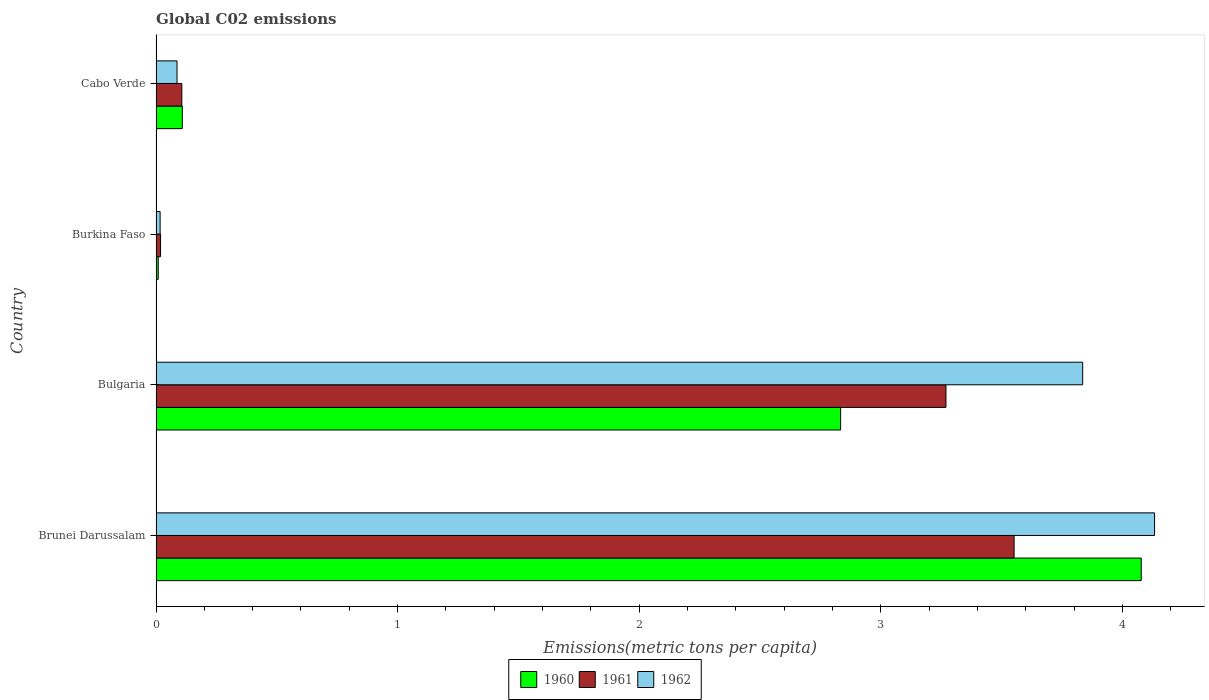How many different coloured bars are there?
Keep it short and to the point. 3. What is the amount of CO2 emitted in in 1961 in Burkina Faso?
Ensure brevity in your answer.  0.02. Across all countries, what is the maximum amount of CO2 emitted in in 1961?
Your response must be concise. 3.55. Across all countries, what is the minimum amount of CO2 emitted in in 1961?
Provide a succinct answer. 0.02. In which country was the amount of CO2 emitted in in 1962 maximum?
Your response must be concise. Brunei Darussalam. In which country was the amount of CO2 emitted in in 1961 minimum?
Provide a succinct answer. Burkina Faso. What is the total amount of CO2 emitted in in 1960 in the graph?
Provide a short and direct response. 7.03. What is the difference between the amount of CO2 emitted in in 1961 in Brunei Darussalam and that in Cabo Verde?
Give a very brief answer. 3.45. What is the difference between the amount of CO2 emitted in in 1961 in Brunei Darussalam and the amount of CO2 emitted in in 1962 in Bulgaria?
Ensure brevity in your answer.  -0.28. What is the average amount of CO2 emitted in in 1960 per country?
Make the answer very short. 1.76. What is the difference between the amount of CO2 emitted in in 1962 and amount of CO2 emitted in in 1960 in Burkina Faso?
Offer a terse response. 0.01. In how many countries, is the amount of CO2 emitted in in 1960 greater than 2.6 metric tons per capita?
Give a very brief answer. 2. What is the ratio of the amount of CO2 emitted in in 1962 in Bulgaria to that in Burkina Faso?
Offer a very short reply. 225.6. Is the difference between the amount of CO2 emitted in in 1962 in Brunei Darussalam and Burkina Faso greater than the difference between the amount of CO2 emitted in in 1960 in Brunei Darussalam and Burkina Faso?
Your answer should be compact. Yes. What is the difference between the highest and the second highest amount of CO2 emitted in in 1961?
Your response must be concise. 0.28. What is the difference between the highest and the lowest amount of CO2 emitted in in 1960?
Your response must be concise. 4.07. Is the sum of the amount of CO2 emitted in in 1961 in Brunei Darussalam and Bulgaria greater than the maximum amount of CO2 emitted in in 1960 across all countries?
Offer a terse response. Yes. How many bars are there?
Provide a succinct answer. 12. How many countries are there in the graph?
Offer a very short reply. 4. What is the difference between two consecutive major ticks on the X-axis?
Give a very brief answer. 1. Are the values on the major ticks of X-axis written in scientific E-notation?
Your answer should be very brief. No. Does the graph contain any zero values?
Ensure brevity in your answer.  No. Where does the legend appear in the graph?
Your response must be concise. Bottom center. What is the title of the graph?
Provide a short and direct response. Global C02 emissions. What is the label or title of the X-axis?
Offer a terse response. Emissions(metric tons per capita). What is the Emissions(metric tons per capita) in 1960 in Brunei Darussalam?
Your answer should be very brief. 4.08. What is the Emissions(metric tons per capita) in 1961 in Brunei Darussalam?
Provide a succinct answer. 3.55. What is the Emissions(metric tons per capita) in 1962 in Brunei Darussalam?
Provide a short and direct response. 4.13. What is the Emissions(metric tons per capita) in 1960 in Bulgaria?
Provide a short and direct response. 2.83. What is the Emissions(metric tons per capita) in 1961 in Bulgaria?
Offer a very short reply. 3.27. What is the Emissions(metric tons per capita) of 1962 in Bulgaria?
Your response must be concise. 3.84. What is the Emissions(metric tons per capita) in 1960 in Burkina Faso?
Offer a terse response. 0.01. What is the Emissions(metric tons per capita) in 1961 in Burkina Faso?
Your answer should be very brief. 0.02. What is the Emissions(metric tons per capita) of 1962 in Burkina Faso?
Provide a succinct answer. 0.02. What is the Emissions(metric tons per capita) in 1960 in Cabo Verde?
Make the answer very short. 0.11. What is the Emissions(metric tons per capita) of 1961 in Cabo Verde?
Give a very brief answer. 0.11. What is the Emissions(metric tons per capita) of 1962 in Cabo Verde?
Give a very brief answer. 0.09. Across all countries, what is the maximum Emissions(metric tons per capita) of 1960?
Offer a terse response. 4.08. Across all countries, what is the maximum Emissions(metric tons per capita) of 1961?
Ensure brevity in your answer.  3.55. Across all countries, what is the maximum Emissions(metric tons per capita) of 1962?
Your response must be concise. 4.13. Across all countries, what is the minimum Emissions(metric tons per capita) in 1960?
Provide a succinct answer. 0.01. Across all countries, what is the minimum Emissions(metric tons per capita) of 1961?
Your response must be concise. 0.02. Across all countries, what is the minimum Emissions(metric tons per capita) of 1962?
Your answer should be very brief. 0.02. What is the total Emissions(metric tons per capita) of 1960 in the graph?
Your response must be concise. 7.03. What is the total Emissions(metric tons per capita) in 1961 in the graph?
Your response must be concise. 6.95. What is the total Emissions(metric tons per capita) in 1962 in the graph?
Provide a short and direct response. 8.07. What is the difference between the Emissions(metric tons per capita) of 1960 in Brunei Darussalam and that in Bulgaria?
Make the answer very short. 1.24. What is the difference between the Emissions(metric tons per capita) in 1961 in Brunei Darussalam and that in Bulgaria?
Keep it short and to the point. 0.28. What is the difference between the Emissions(metric tons per capita) in 1962 in Brunei Darussalam and that in Bulgaria?
Ensure brevity in your answer.  0.3. What is the difference between the Emissions(metric tons per capita) in 1960 in Brunei Darussalam and that in Burkina Faso?
Keep it short and to the point. 4.07. What is the difference between the Emissions(metric tons per capita) of 1961 in Brunei Darussalam and that in Burkina Faso?
Keep it short and to the point. 3.53. What is the difference between the Emissions(metric tons per capita) in 1962 in Brunei Darussalam and that in Burkina Faso?
Your answer should be compact. 4.12. What is the difference between the Emissions(metric tons per capita) of 1960 in Brunei Darussalam and that in Cabo Verde?
Offer a terse response. 3.97. What is the difference between the Emissions(metric tons per capita) in 1961 in Brunei Darussalam and that in Cabo Verde?
Your answer should be compact. 3.45. What is the difference between the Emissions(metric tons per capita) in 1962 in Brunei Darussalam and that in Cabo Verde?
Your answer should be very brief. 4.05. What is the difference between the Emissions(metric tons per capita) in 1960 in Bulgaria and that in Burkina Faso?
Make the answer very short. 2.82. What is the difference between the Emissions(metric tons per capita) in 1961 in Bulgaria and that in Burkina Faso?
Give a very brief answer. 3.25. What is the difference between the Emissions(metric tons per capita) of 1962 in Bulgaria and that in Burkina Faso?
Ensure brevity in your answer.  3.82. What is the difference between the Emissions(metric tons per capita) in 1960 in Bulgaria and that in Cabo Verde?
Your answer should be very brief. 2.73. What is the difference between the Emissions(metric tons per capita) in 1961 in Bulgaria and that in Cabo Verde?
Make the answer very short. 3.16. What is the difference between the Emissions(metric tons per capita) of 1962 in Bulgaria and that in Cabo Verde?
Your answer should be compact. 3.75. What is the difference between the Emissions(metric tons per capita) of 1960 in Burkina Faso and that in Cabo Verde?
Offer a very short reply. -0.1. What is the difference between the Emissions(metric tons per capita) in 1961 in Burkina Faso and that in Cabo Verde?
Offer a terse response. -0.09. What is the difference between the Emissions(metric tons per capita) in 1962 in Burkina Faso and that in Cabo Verde?
Ensure brevity in your answer.  -0.07. What is the difference between the Emissions(metric tons per capita) in 1960 in Brunei Darussalam and the Emissions(metric tons per capita) in 1961 in Bulgaria?
Keep it short and to the point. 0.81. What is the difference between the Emissions(metric tons per capita) in 1960 in Brunei Darussalam and the Emissions(metric tons per capita) in 1962 in Bulgaria?
Ensure brevity in your answer.  0.24. What is the difference between the Emissions(metric tons per capita) of 1961 in Brunei Darussalam and the Emissions(metric tons per capita) of 1962 in Bulgaria?
Your response must be concise. -0.28. What is the difference between the Emissions(metric tons per capita) in 1960 in Brunei Darussalam and the Emissions(metric tons per capita) in 1961 in Burkina Faso?
Offer a very short reply. 4.06. What is the difference between the Emissions(metric tons per capita) of 1960 in Brunei Darussalam and the Emissions(metric tons per capita) of 1962 in Burkina Faso?
Provide a short and direct response. 4.06. What is the difference between the Emissions(metric tons per capita) of 1961 in Brunei Darussalam and the Emissions(metric tons per capita) of 1962 in Burkina Faso?
Ensure brevity in your answer.  3.54. What is the difference between the Emissions(metric tons per capita) of 1960 in Brunei Darussalam and the Emissions(metric tons per capita) of 1961 in Cabo Verde?
Offer a terse response. 3.97. What is the difference between the Emissions(metric tons per capita) of 1960 in Brunei Darussalam and the Emissions(metric tons per capita) of 1962 in Cabo Verde?
Provide a short and direct response. 3.99. What is the difference between the Emissions(metric tons per capita) of 1961 in Brunei Darussalam and the Emissions(metric tons per capita) of 1962 in Cabo Verde?
Your answer should be compact. 3.47. What is the difference between the Emissions(metric tons per capita) in 1960 in Bulgaria and the Emissions(metric tons per capita) in 1961 in Burkina Faso?
Your answer should be very brief. 2.82. What is the difference between the Emissions(metric tons per capita) in 1960 in Bulgaria and the Emissions(metric tons per capita) in 1962 in Burkina Faso?
Keep it short and to the point. 2.82. What is the difference between the Emissions(metric tons per capita) in 1961 in Bulgaria and the Emissions(metric tons per capita) in 1962 in Burkina Faso?
Your answer should be very brief. 3.25. What is the difference between the Emissions(metric tons per capita) of 1960 in Bulgaria and the Emissions(metric tons per capita) of 1961 in Cabo Verde?
Your answer should be very brief. 2.73. What is the difference between the Emissions(metric tons per capita) of 1960 in Bulgaria and the Emissions(metric tons per capita) of 1962 in Cabo Verde?
Your response must be concise. 2.75. What is the difference between the Emissions(metric tons per capita) in 1961 in Bulgaria and the Emissions(metric tons per capita) in 1962 in Cabo Verde?
Provide a short and direct response. 3.18. What is the difference between the Emissions(metric tons per capita) in 1960 in Burkina Faso and the Emissions(metric tons per capita) in 1961 in Cabo Verde?
Provide a short and direct response. -0.1. What is the difference between the Emissions(metric tons per capita) of 1960 in Burkina Faso and the Emissions(metric tons per capita) of 1962 in Cabo Verde?
Provide a succinct answer. -0.08. What is the difference between the Emissions(metric tons per capita) of 1961 in Burkina Faso and the Emissions(metric tons per capita) of 1962 in Cabo Verde?
Offer a very short reply. -0.07. What is the average Emissions(metric tons per capita) of 1960 per country?
Ensure brevity in your answer.  1.76. What is the average Emissions(metric tons per capita) in 1961 per country?
Offer a terse response. 1.74. What is the average Emissions(metric tons per capita) in 1962 per country?
Offer a terse response. 2.02. What is the difference between the Emissions(metric tons per capita) of 1960 and Emissions(metric tons per capita) of 1961 in Brunei Darussalam?
Provide a short and direct response. 0.53. What is the difference between the Emissions(metric tons per capita) in 1960 and Emissions(metric tons per capita) in 1962 in Brunei Darussalam?
Your answer should be compact. -0.06. What is the difference between the Emissions(metric tons per capita) in 1961 and Emissions(metric tons per capita) in 1962 in Brunei Darussalam?
Keep it short and to the point. -0.58. What is the difference between the Emissions(metric tons per capita) of 1960 and Emissions(metric tons per capita) of 1961 in Bulgaria?
Ensure brevity in your answer.  -0.44. What is the difference between the Emissions(metric tons per capita) in 1960 and Emissions(metric tons per capita) in 1962 in Bulgaria?
Offer a very short reply. -1. What is the difference between the Emissions(metric tons per capita) in 1961 and Emissions(metric tons per capita) in 1962 in Bulgaria?
Offer a terse response. -0.57. What is the difference between the Emissions(metric tons per capita) of 1960 and Emissions(metric tons per capita) of 1961 in Burkina Faso?
Provide a short and direct response. -0.01. What is the difference between the Emissions(metric tons per capita) of 1960 and Emissions(metric tons per capita) of 1962 in Burkina Faso?
Your answer should be compact. -0.01. What is the difference between the Emissions(metric tons per capita) of 1961 and Emissions(metric tons per capita) of 1962 in Burkina Faso?
Ensure brevity in your answer.  0. What is the difference between the Emissions(metric tons per capita) in 1960 and Emissions(metric tons per capita) in 1961 in Cabo Verde?
Offer a very short reply. 0. What is the difference between the Emissions(metric tons per capita) of 1960 and Emissions(metric tons per capita) of 1962 in Cabo Verde?
Offer a very short reply. 0.02. What is the difference between the Emissions(metric tons per capita) in 1961 and Emissions(metric tons per capita) in 1962 in Cabo Verde?
Give a very brief answer. 0.02. What is the ratio of the Emissions(metric tons per capita) in 1960 in Brunei Darussalam to that in Bulgaria?
Give a very brief answer. 1.44. What is the ratio of the Emissions(metric tons per capita) in 1961 in Brunei Darussalam to that in Bulgaria?
Provide a short and direct response. 1.09. What is the ratio of the Emissions(metric tons per capita) of 1962 in Brunei Darussalam to that in Bulgaria?
Your answer should be very brief. 1.08. What is the ratio of the Emissions(metric tons per capita) in 1960 in Brunei Darussalam to that in Burkina Faso?
Offer a terse response. 447.57. What is the ratio of the Emissions(metric tons per capita) of 1961 in Brunei Darussalam to that in Burkina Faso?
Keep it short and to the point. 189.64. What is the ratio of the Emissions(metric tons per capita) in 1962 in Brunei Darussalam to that in Burkina Faso?
Keep it short and to the point. 243.1. What is the ratio of the Emissions(metric tons per capita) in 1960 in Brunei Darussalam to that in Cabo Verde?
Provide a short and direct response. 37.5. What is the ratio of the Emissions(metric tons per capita) in 1961 in Brunei Darussalam to that in Cabo Verde?
Your answer should be very brief. 33.25. What is the ratio of the Emissions(metric tons per capita) in 1962 in Brunei Darussalam to that in Cabo Verde?
Provide a short and direct response. 47.54. What is the ratio of the Emissions(metric tons per capita) in 1960 in Bulgaria to that in Burkina Faso?
Your answer should be compact. 311.01. What is the ratio of the Emissions(metric tons per capita) in 1961 in Bulgaria to that in Burkina Faso?
Offer a terse response. 174.58. What is the ratio of the Emissions(metric tons per capita) of 1962 in Bulgaria to that in Burkina Faso?
Provide a succinct answer. 225.6. What is the ratio of the Emissions(metric tons per capita) of 1960 in Bulgaria to that in Cabo Verde?
Provide a succinct answer. 26.06. What is the ratio of the Emissions(metric tons per capita) in 1961 in Bulgaria to that in Cabo Verde?
Make the answer very short. 30.61. What is the ratio of the Emissions(metric tons per capita) of 1962 in Bulgaria to that in Cabo Verde?
Give a very brief answer. 44.12. What is the ratio of the Emissions(metric tons per capita) of 1960 in Burkina Faso to that in Cabo Verde?
Your response must be concise. 0.08. What is the ratio of the Emissions(metric tons per capita) of 1961 in Burkina Faso to that in Cabo Verde?
Your answer should be very brief. 0.18. What is the ratio of the Emissions(metric tons per capita) in 1962 in Burkina Faso to that in Cabo Verde?
Offer a very short reply. 0.2. What is the difference between the highest and the second highest Emissions(metric tons per capita) in 1960?
Provide a succinct answer. 1.24. What is the difference between the highest and the second highest Emissions(metric tons per capita) of 1961?
Keep it short and to the point. 0.28. What is the difference between the highest and the second highest Emissions(metric tons per capita) of 1962?
Keep it short and to the point. 0.3. What is the difference between the highest and the lowest Emissions(metric tons per capita) of 1960?
Your response must be concise. 4.07. What is the difference between the highest and the lowest Emissions(metric tons per capita) of 1961?
Ensure brevity in your answer.  3.53. What is the difference between the highest and the lowest Emissions(metric tons per capita) in 1962?
Provide a short and direct response. 4.12. 